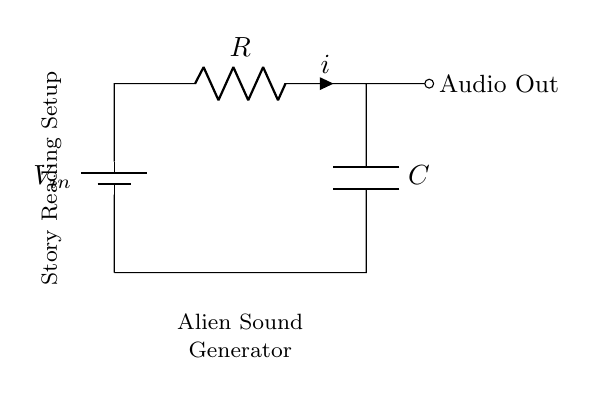What type of circuit is represented? The circuit is an RC timing circuit, which includes a resistor and a capacitor used for timing purposes.
Answer: RC timing What are the main components in the circuit? The main components are a resistor and a capacitor, which are connected to a battery providing the input voltage.
Answer: Resistor and capacitor What does the current flow direction represent? The current direction flows from the positive terminal of the battery through the resistor to the capacitor and then returns to the battery.
Answer: From battery to resistor to capacitor What is the role of the capacitor in this circuit? The capacitor stores electrical energy and releases it over time, creating a delay effect, which is essential for generating sound effects.
Answer: Store energy What type of output does this circuit provide? The output is audio, which can be used to create alien-like sound effects in a story reading setup.
Answer: Audio output If the resistor's value is increased, what happens to the timing of the circuit? Increasing the resistance increases the time constant, which means the capacitor charges and discharges more slowly, resulting in longer delays in sound production.
Answer: Longer timing 